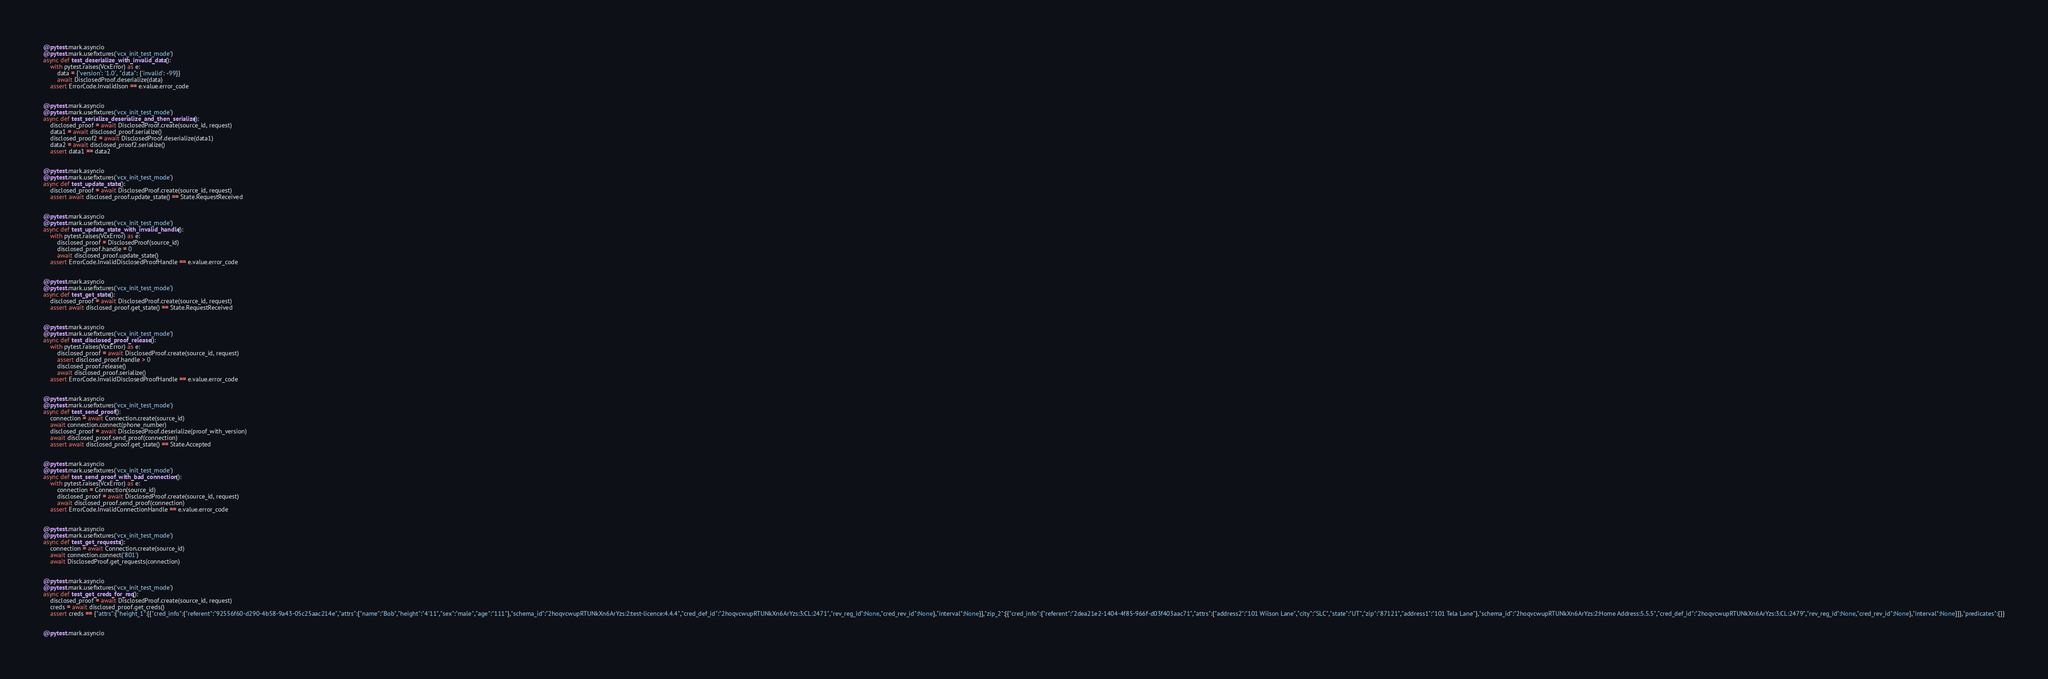<code> <loc_0><loc_0><loc_500><loc_500><_Python_>

@pytest.mark.asyncio
@pytest.mark.usefixtures('vcx_init_test_mode')
async def test_deserialize_with_invalid_data():
    with pytest.raises(VcxError) as e:
        data = {'version': '1.0', "data": {'invalid': -99}}
        await DisclosedProof.deserialize(data)
    assert ErrorCode.InvalidJson == e.value.error_code


@pytest.mark.asyncio
@pytest.mark.usefixtures('vcx_init_test_mode')
async def test_serialize_deserialize_and_then_serialize():
    disclosed_proof = await DisclosedProof.create(source_id, request)
    data1 = await disclosed_proof.serialize()
    disclosed_proof2 = await DisclosedProof.deserialize(data1)
    data2 = await disclosed_proof2.serialize()
    assert data1 == data2


@pytest.mark.asyncio
@pytest.mark.usefixtures('vcx_init_test_mode')
async def test_update_state():
    disclosed_proof = await DisclosedProof.create(source_id, request)
    assert await disclosed_proof.update_state() == State.RequestReceived


@pytest.mark.asyncio
@pytest.mark.usefixtures('vcx_init_test_mode')
async def test_update_state_with_invalid_handle():
    with pytest.raises(VcxError) as e:
        disclosed_proof = DisclosedProof(source_id)
        disclosed_proof.handle = 0
        await disclosed_proof.update_state()
    assert ErrorCode.InvalidDisclosedProofHandle == e.value.error_code


@pytest.mark.asyncio
@pytest.mark.usefixtures('vcx_init_test_mode')
async def test_get_state():
    disclosed_proof = await DisclosedProof.create(source_id, request)
    assert await disclosed_proof.get_state() == State.RequestReceived


@pytest.mark.asyncio
@pytest.mark.usefixtures('vcx_init_test_mode')
async def test_disclosed_proof_release():
    with pytest.raises(VcxError) as e:
        disclosed_proof = await DisclosedProof.create(source_id, request)
        assert disclosed_proof.handle > 0
        disclosed_proof.release()
        await disclosed_proof.serialize()
    assert ErrorCode.InvalidDisclosedProofHandle == e.value.error_code


@pytest.mark.asyncio
@pytest.mark.usefixtures('vcx_init_test_mode')
async def test_send_proof():
    connection = await Connection.create(source_id)
    await connection.connect(phone_number)
    disclosed_proof = await DisclosedProof.deserialize(proof_with_version)
    await disclosed_proof.send_proof(connection)
    assert await disclosed_proof.get_state() == State.Accepted


@pytest.mark.asyncio
@pytest.mark.usefixtures('vcx_init_test_mode')
async def test_send_proof_with_bad_connection():
    with pytest.raises(VcxError) as e:
        connection = Connection(source_id)
        disclosed_proof = await DisclosedProof.create(source_id, request)
        await disclosed_proof.send_proof(connection)
    assert ErrorCode.InvalidConnectionHandle == e.value.error_code


@pytest.mark.asyncio
@pytest.mark.usefixtures('vcx_init_test_mode')
async def test_get_requests():
    connection = await Connection.create(source_id)
    await connection.connect('801')
    await DisclosedProof.get_requests(connection)


@pytest.mark.asyncio
@pytest.mark.usefixtures('vcx_init_test_mode')
async def test_get_creds_for_req():
    disclosed_proof = await DisclosedProof.create(source_id, request)
    creds = await disclosed_proof.get_creds()
    assert creds == {"attrs":{"height_1":[{"cred_info":{"referent":"92556f60-d290-4b58-9a43-05c25aac214e","attrs":{"name":"Bob","height":"4'11","sex":"male","age":"111"},"schema_id":"2hoqvcwupRTUNkXn6ArYzs:2:test-licence:4.4.4","cred_def_id":"2hoqvcwupRTUNkXn6ArYzs:3:CL:2471","rev_reg_id":None,"cred_rev_id":None},"interval":None}],"zip_2":[{"cred_info":{"referent":"2dea21e2-1404-4f85-966f-d03f403aac71","attrs":{"address2":"101 Wilson Lane","city":"SLC","state":"UT","zip":"87121","address1":"101 Tela Lane"},"schema_id":"2hoqvcwupRTUNkXn6ArYzs:2:Home Address:5.5.5","cred_def_id":"2hoqvcwupRTUNkXn6ArYzs:3:CL:2479","rev_reg_id":None,"cred_rev_id":None},"interval":None}]},"predicates":{}}


@pytest.mark.asyncio</code> 